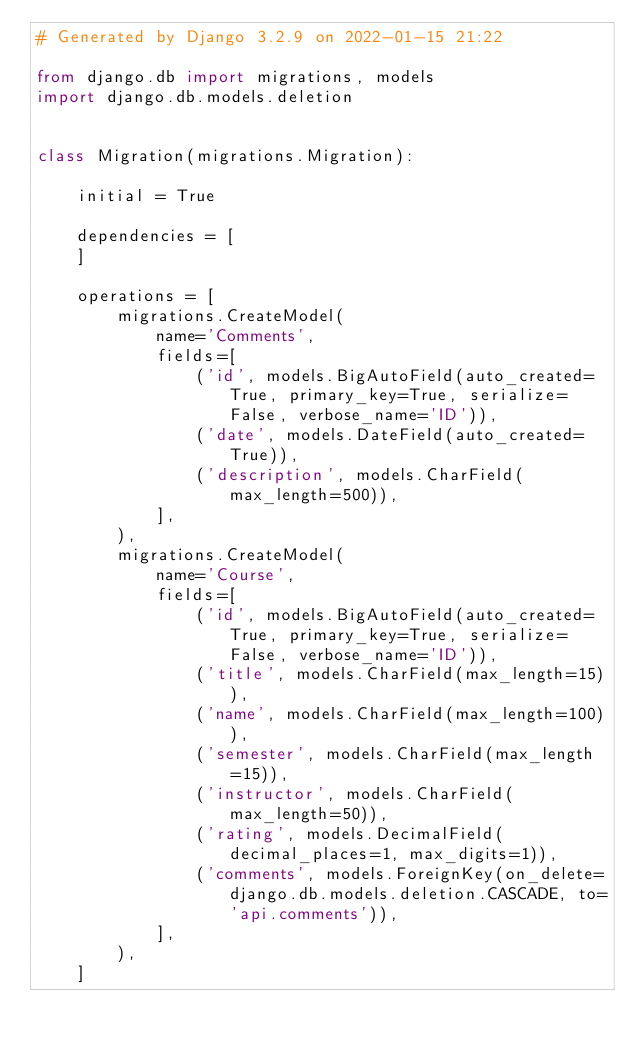<code> <loc_0><loc_0><loc_500><loc_500><_Python_># Generated by Django 3.2.9 on 2022-01-15 21:22

from django.db import migrations, models
import django.db.models.deletion


class Migration(migrations.Migration):

    initial = True

    dependencies = [
    ]

    operations = [
        migrations.CreateModel(
            name='Comments',
            fields=[
                ('id', models.BigAutoField(auto_created=True, primary_key=True, serialize=False, verbose_name='ID')),
                ('date', models.DateField(auto_created=True)),
                ('description', models.CharField(max_length=500)),
            ],
        ),
        migrations.CreateModel(
            name='Course',
            fields=[
                ('id', models.BigAutoField(auto_created=True, primary_key=True, serialize=False, verbose_name='ID')),
                ('title', models.CharField(max_length=15)),
                ('name', models.CharField(max_length=100)),
                ('semester', models.CharField(max_length=15)),
                ('instructor', models.CharField(max_length=50)),
                ('rating', models.DecimalField(decimal_places=1, max_digits=1)),
                ('comments', models.ForeignKey(on_delete=django.db.models.deletion.CASCADE, to='api.comments')),
            ],
        ),
    ]
</code> 